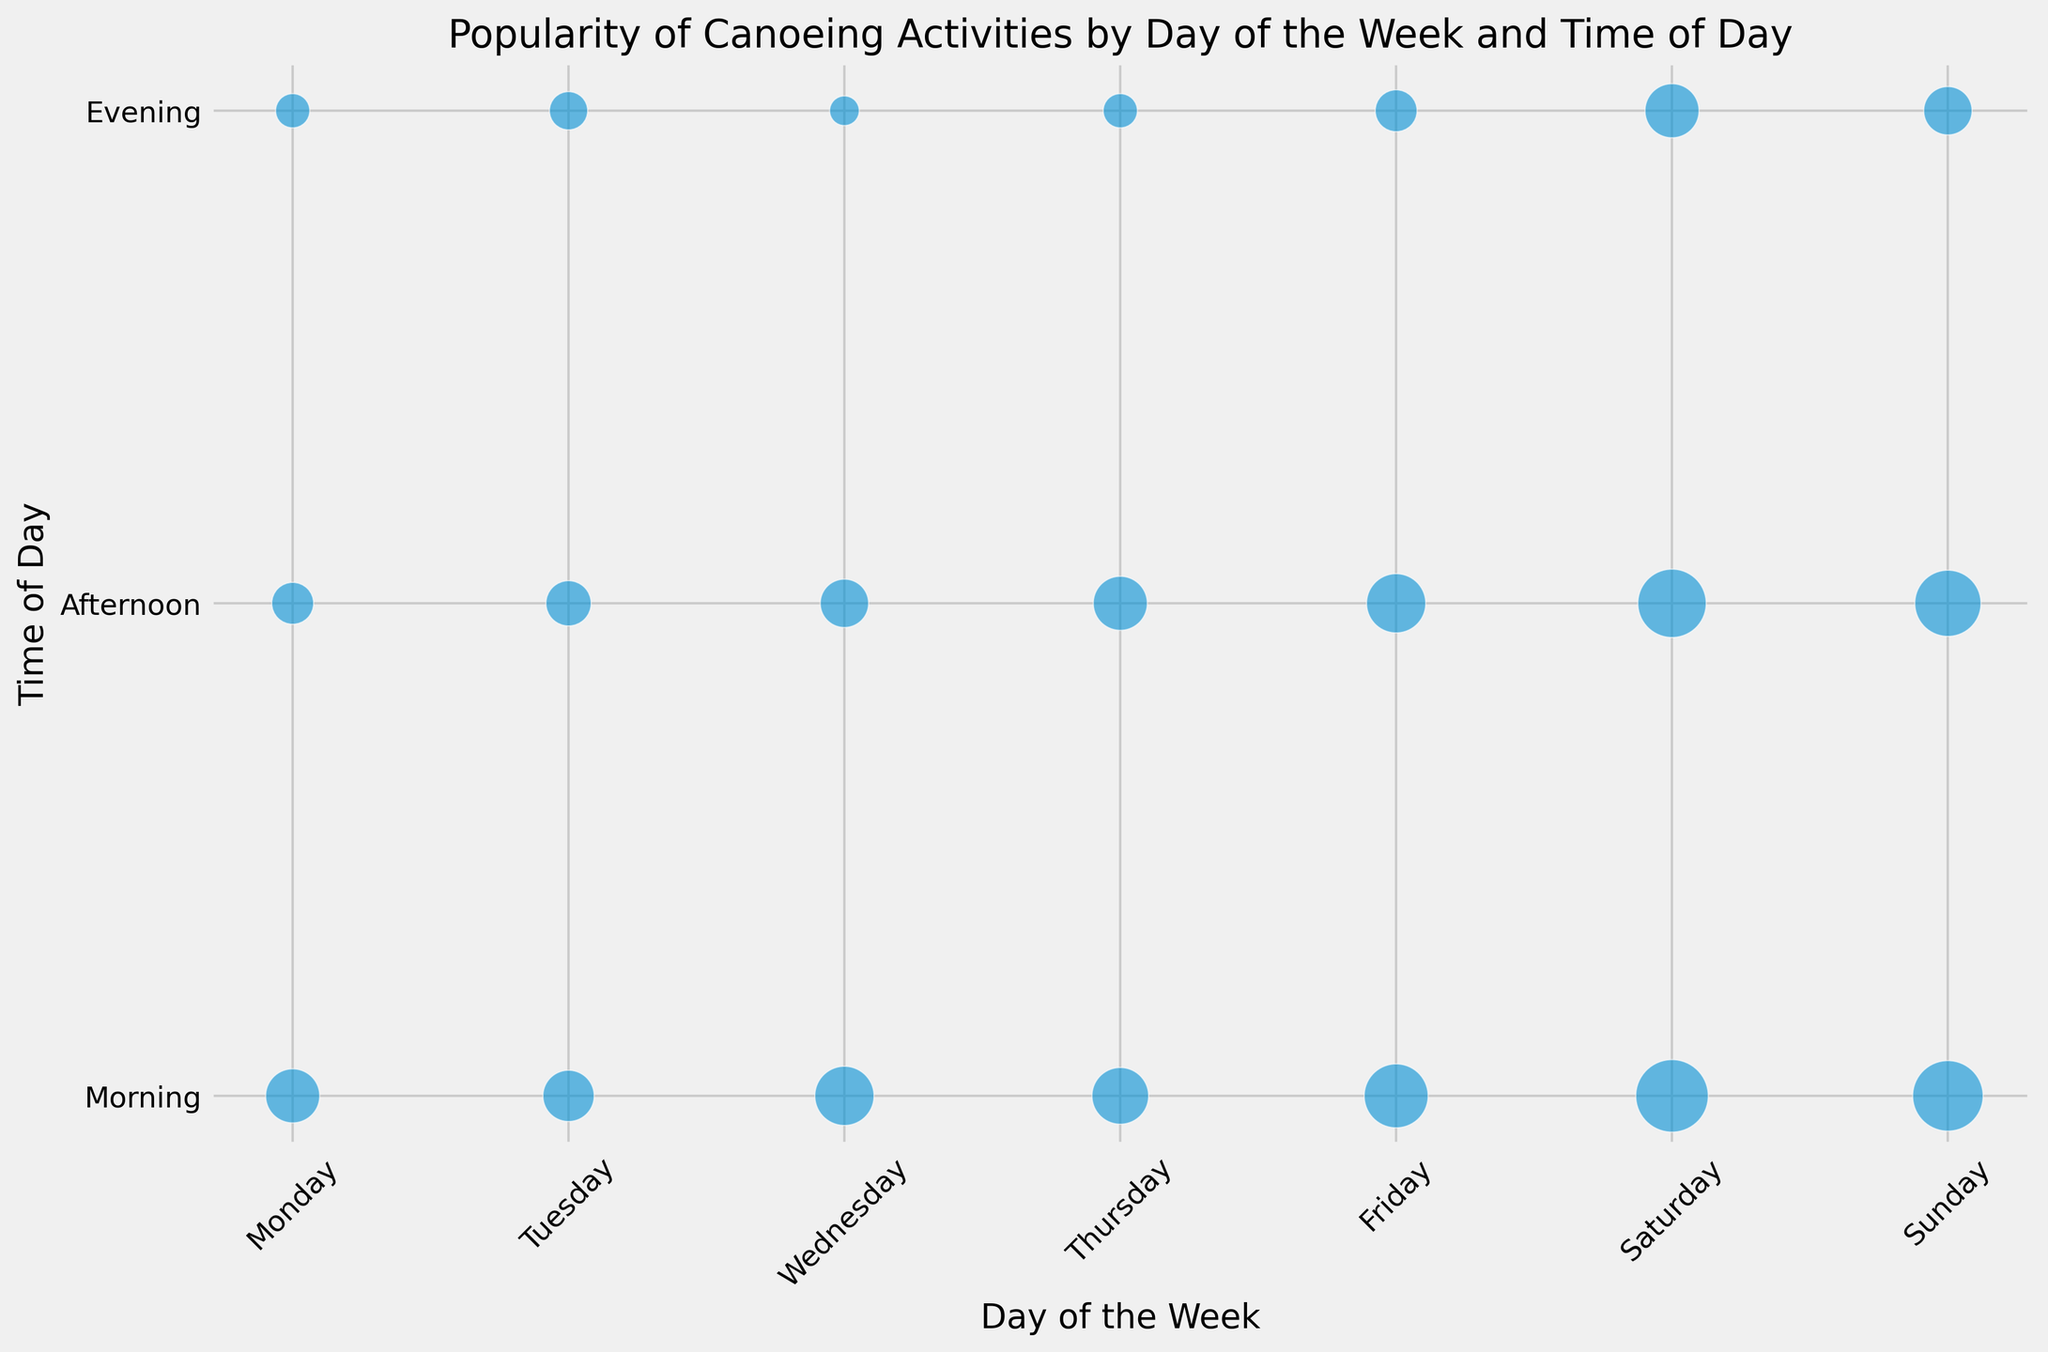Which day has the most popular canoeing activity in the morning? Look for the largest bubble in the morning row. The largest bubble in the morning row is on Saturday.
Answer: Saturday Compare the popularity of canoeing on Friday afternoon with Thursday afternoon. Which one is more popular? Find the bubbles for Friday afternoon and Thursday afternoon. The bubble for Friday afternoon is larger than the one for Thursday afternoon.
Answer: Friday afternoon What is the least popular time for canoeing on Wednesday? Identify the smallest bubble on Wednesday. The evening bubble is the smallest.
Answer: Wednesday evening How much more popular is Saturday morning than Wednesday morning for canoeing? Find the sizes of the bubbles for both Saturday morning and Wednesday morning, then subtract the smaller value from the larger one. The popularity for Saturday morning is 90, and for Wednesday morning it is 60, so 90 - 60 = 30.
Answer: 30 What is the average popularity of canoeing activities on Sunday? Add the popularity values for all three times of day on Sunday and divide by three. (85 + 75 + 40) / 3 = 66.67
Answer: 66.67 On which day is the popularity of canoeing in the evening the highest? Look for the largest bubble in the evening row. The largest bubble in the evening row is on Saturday.
Answer: Saturday How does the popularity of canoeing on Tuesday morning compare to Tuesday afternoon? Compare the sizes of the bubbles for Tuesday morning and Tuesday afternoon. The Tuesday morning bubble is larger than the Tuesday afternoon bubble.
Answer: More popular in the morning What is the total popularity of canoeing in the afternoon from Monday to Sunday? Sum up the sizes of the afternoon bubbles for each day. (30 + 35 + 40 + 50 + 60 + 80 + 75) = 370
Answer: 370 Is canoeing more popular on weekends or weekdays based on the combined popularity? Sum the popularity for Saturday and Sunday, then compare it with the sum for Monday to Friday. Weekends: (90 + 80 + 50 + 85 + 75 + 40) = 420, Weekdays: (50+30+20 + 45+35+25 + 60+40+15 + 55+50+20 + 70+60+30) = 605. Weekdays are more popular.
Answer: Weekdays 